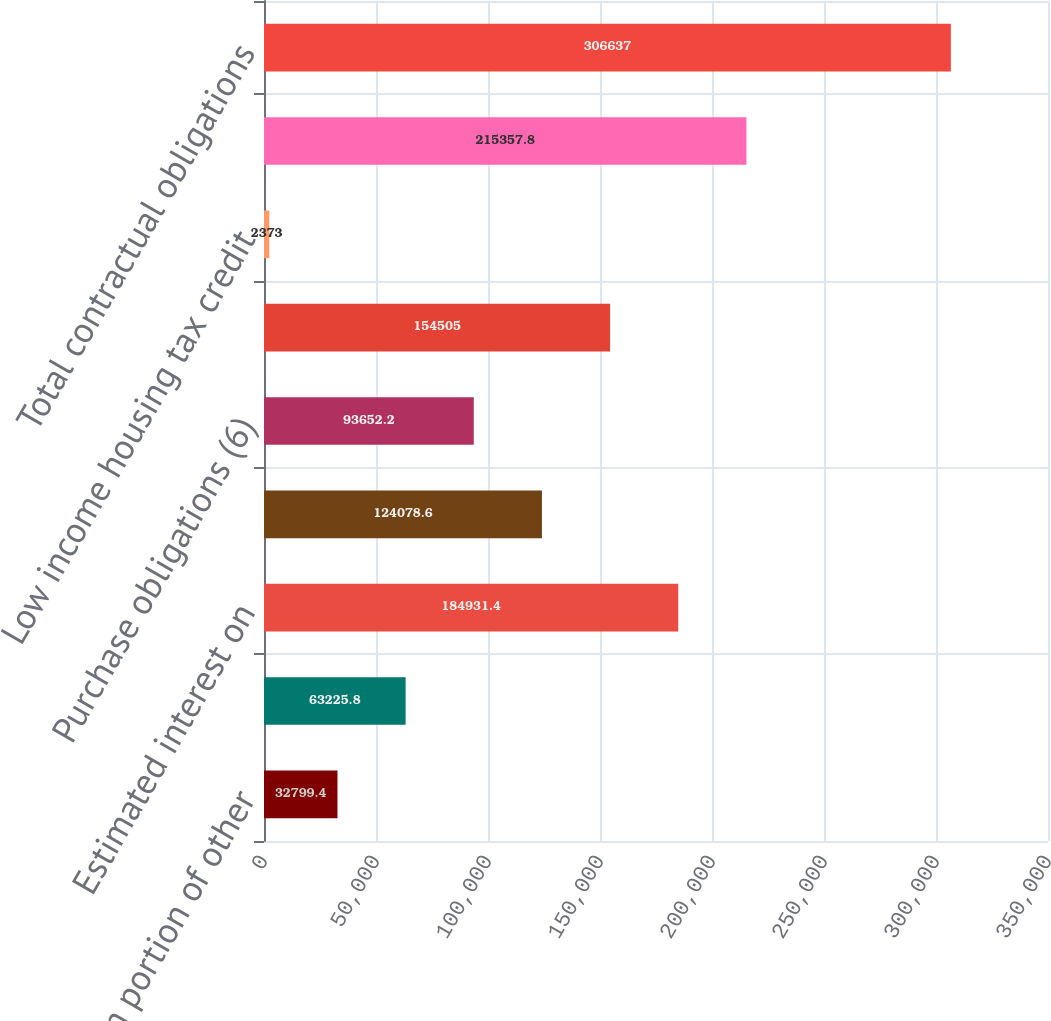Convert chart to OTSL. <chart><loc_0><loc_0><loc_500><loc_500><bar_chart><fcel>Long-term portion of other<fcel>Sub-total long-term debt<fcel>Estimated interest on<fcel>Operating lease obligations<fcel>Purchase obligations (6)<fcel>Deferred compensation programs<fcel>Low income housing tax credit<fcel>Sub-total long-term<fcel>Total contractual obligations<nl><fcel>32799.4<fcel>63225.8<fcel>184931<fcel>124079<fcel>93652.2<fcel>154505<fcel>2373<fcel>215358<fcel>306637<nl></chart> 